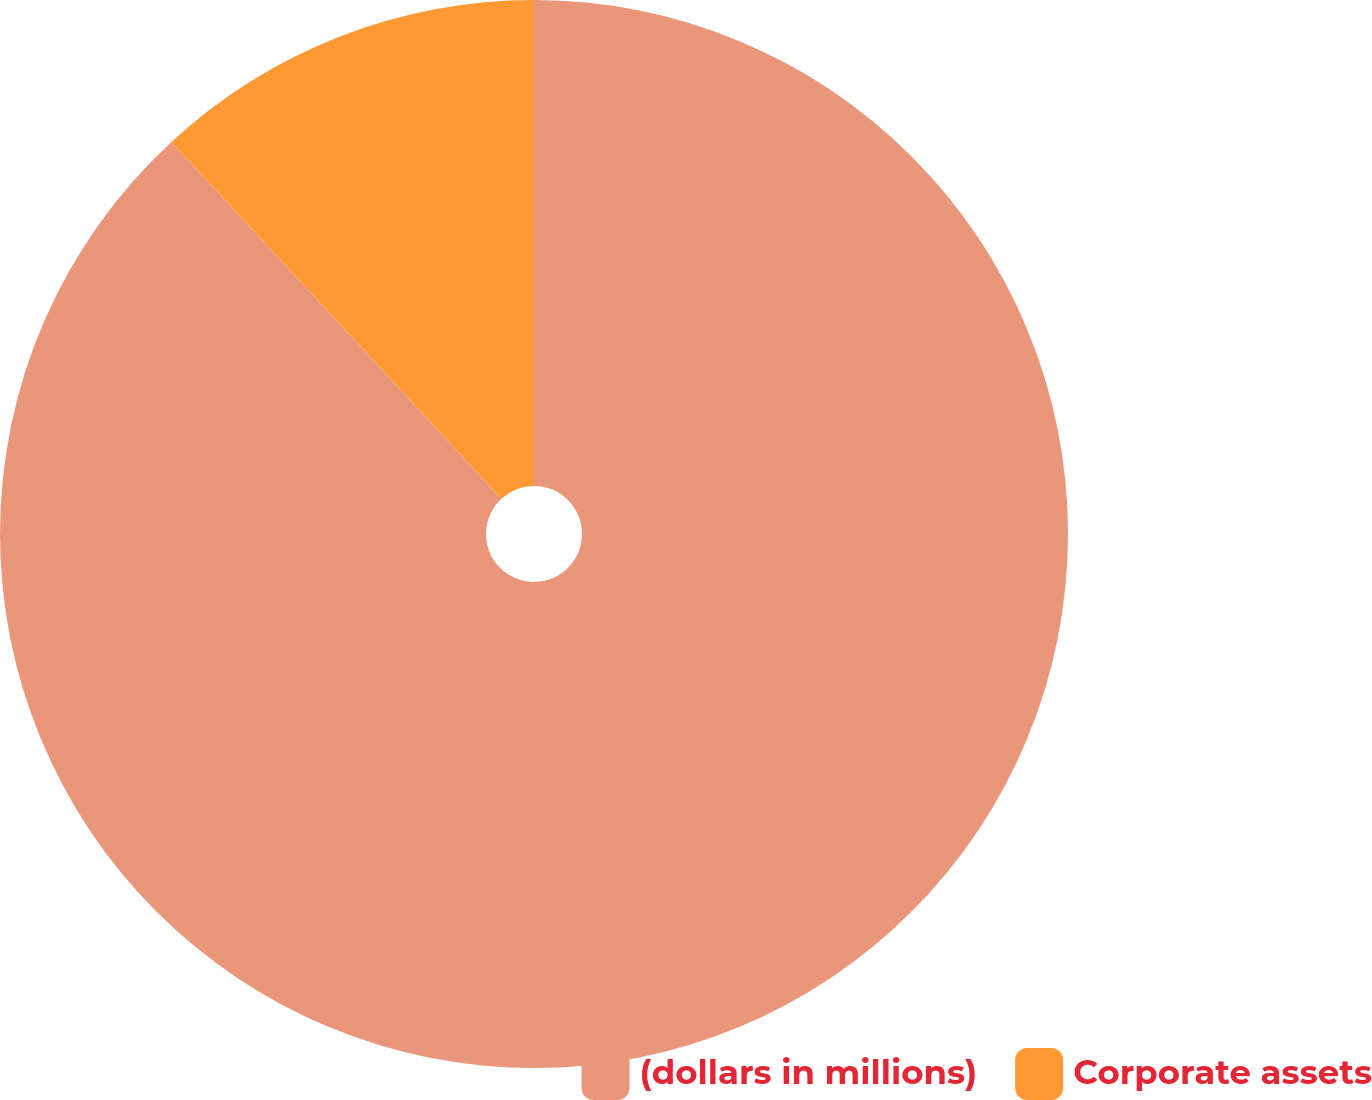Convert chart to OTSL. <chart><loc_0><loc_0><loc_500><loc_500><pie_chart><fcel>(dollars in millions)<fcel>Corporate assets<nl><fcel>88.12%<fcel>11.88%<nl></chart> 